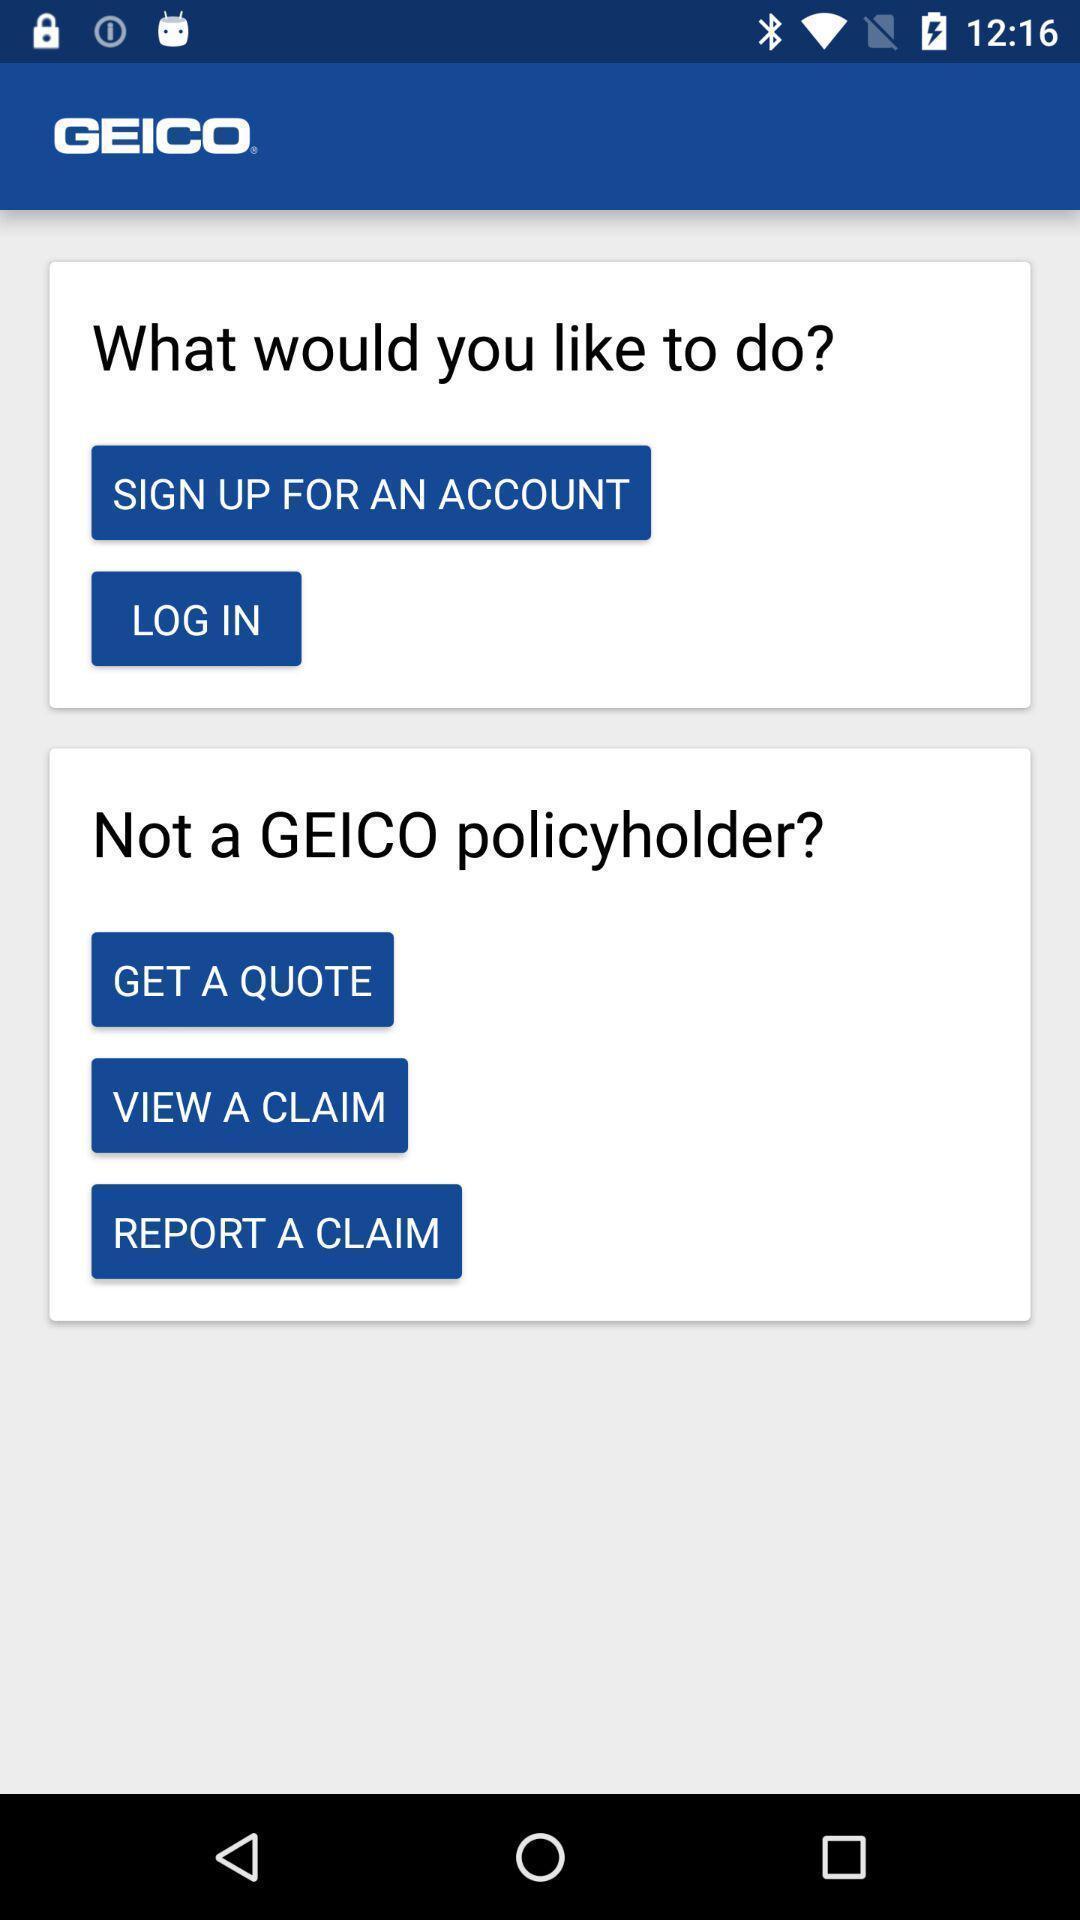Give me a summary of this screen capture. Screen showing login page. 